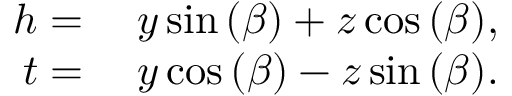Convert formula to latex. <formula><loc_0><loc_0><loc_500><loc_500>\begin{array} { r l } { h } & y \sin { ( \beta ) } + z \cos { ( \beta ) } , } \\ { t } & y \cos { ( \beta ) } - z \sin { ( \beta ) } . } \end{array}</formula> 